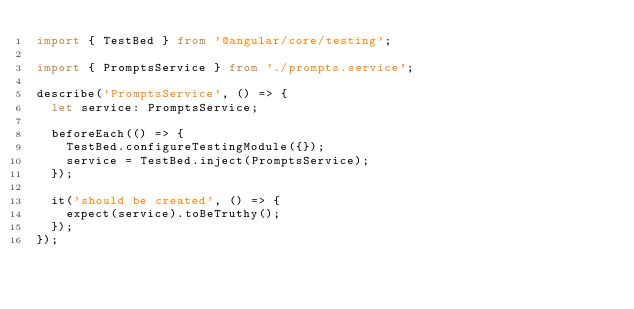Convert code to text. <code><loc_0><loc_0><loc_500><loc_500><_TypeScript_>import { TestBed } from '@angular/core/testing';

import { PromptsService } from './prompts.service';

describe('PromptsService', () => {
  let service: PromptsService;

  beforeEach(() => {
    TestBed.configureTestingModule({});
    service = TestBed.inject(PromptsService);
  });

  it('should be created', () => {
    expect(service).toBeTruthy();
  });
});
</code> 